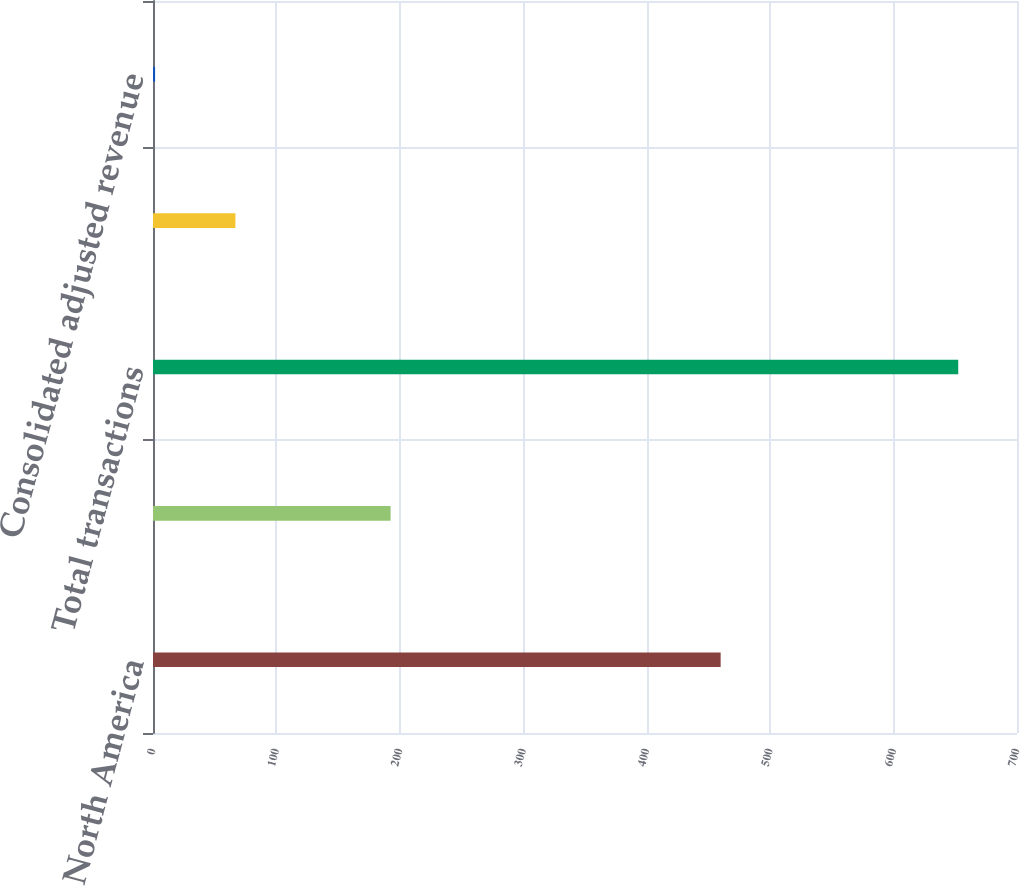Convert chart. <chart><loc_0><loc_0><loc_500><loc_500><bar_chart><fcel>North America<fcel>International<fcel>Total transactions<fcel>Consolidated revenue per<fcel>Consolidated adjusted revenue<nl><fcel>459.9<fcel>192.5<fcel>652.4<fcel>66.76<fcel>1.69<nl></chart> 